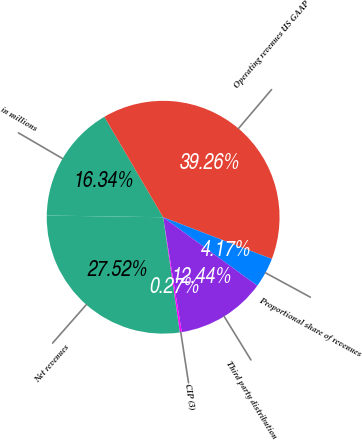Convert chart. <chart><loc_0><loc_0><loc_500><loc_500><pie_chart><fcel>in millions<fcel>Operating revenues US GAAP<fcel>Proportional share of revenues<fcel>Third party distribution<fcel>CIP (3)<fcel>Net revenues<nl><fcel>16.34%<fcel>39.26%<fcel>4.17%<fcel>12.44%<fcel>0.27%<fcel>27.52%<nl></chart> 